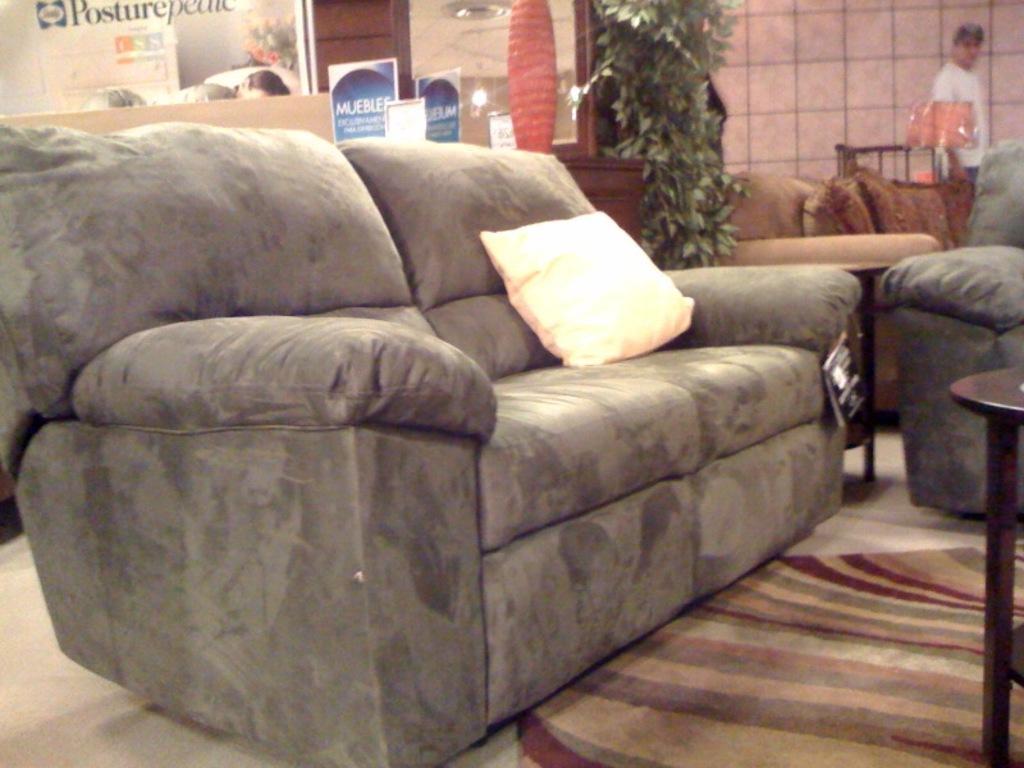Describe this image in one or two sentences. In this image there is one couch and beside that couch another couch is there on these couches there are pillows in the middle of the image there is one plant and on the top of the right corner there is one wall and one person who is standing he is wearing a white shirt and on the floor there is one carpet in front of the couch there is one table. 